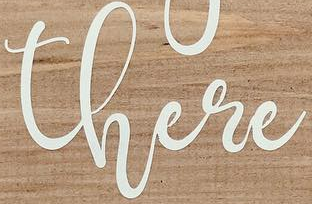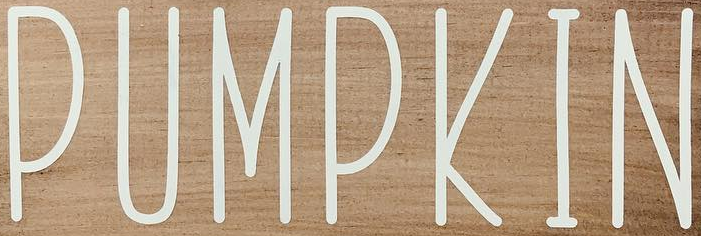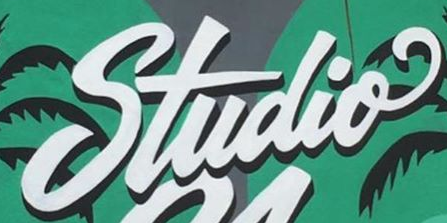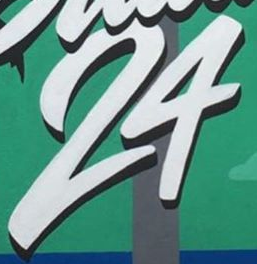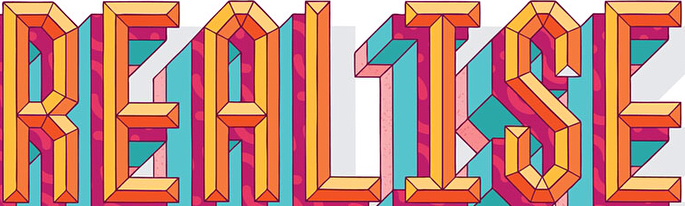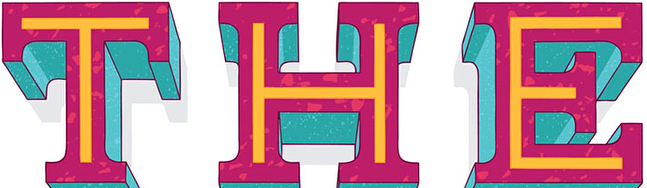Read the text from these images in sequence, separated by a semicolon. there; PUMPKIN; Studio; 24; REALISE; THE 